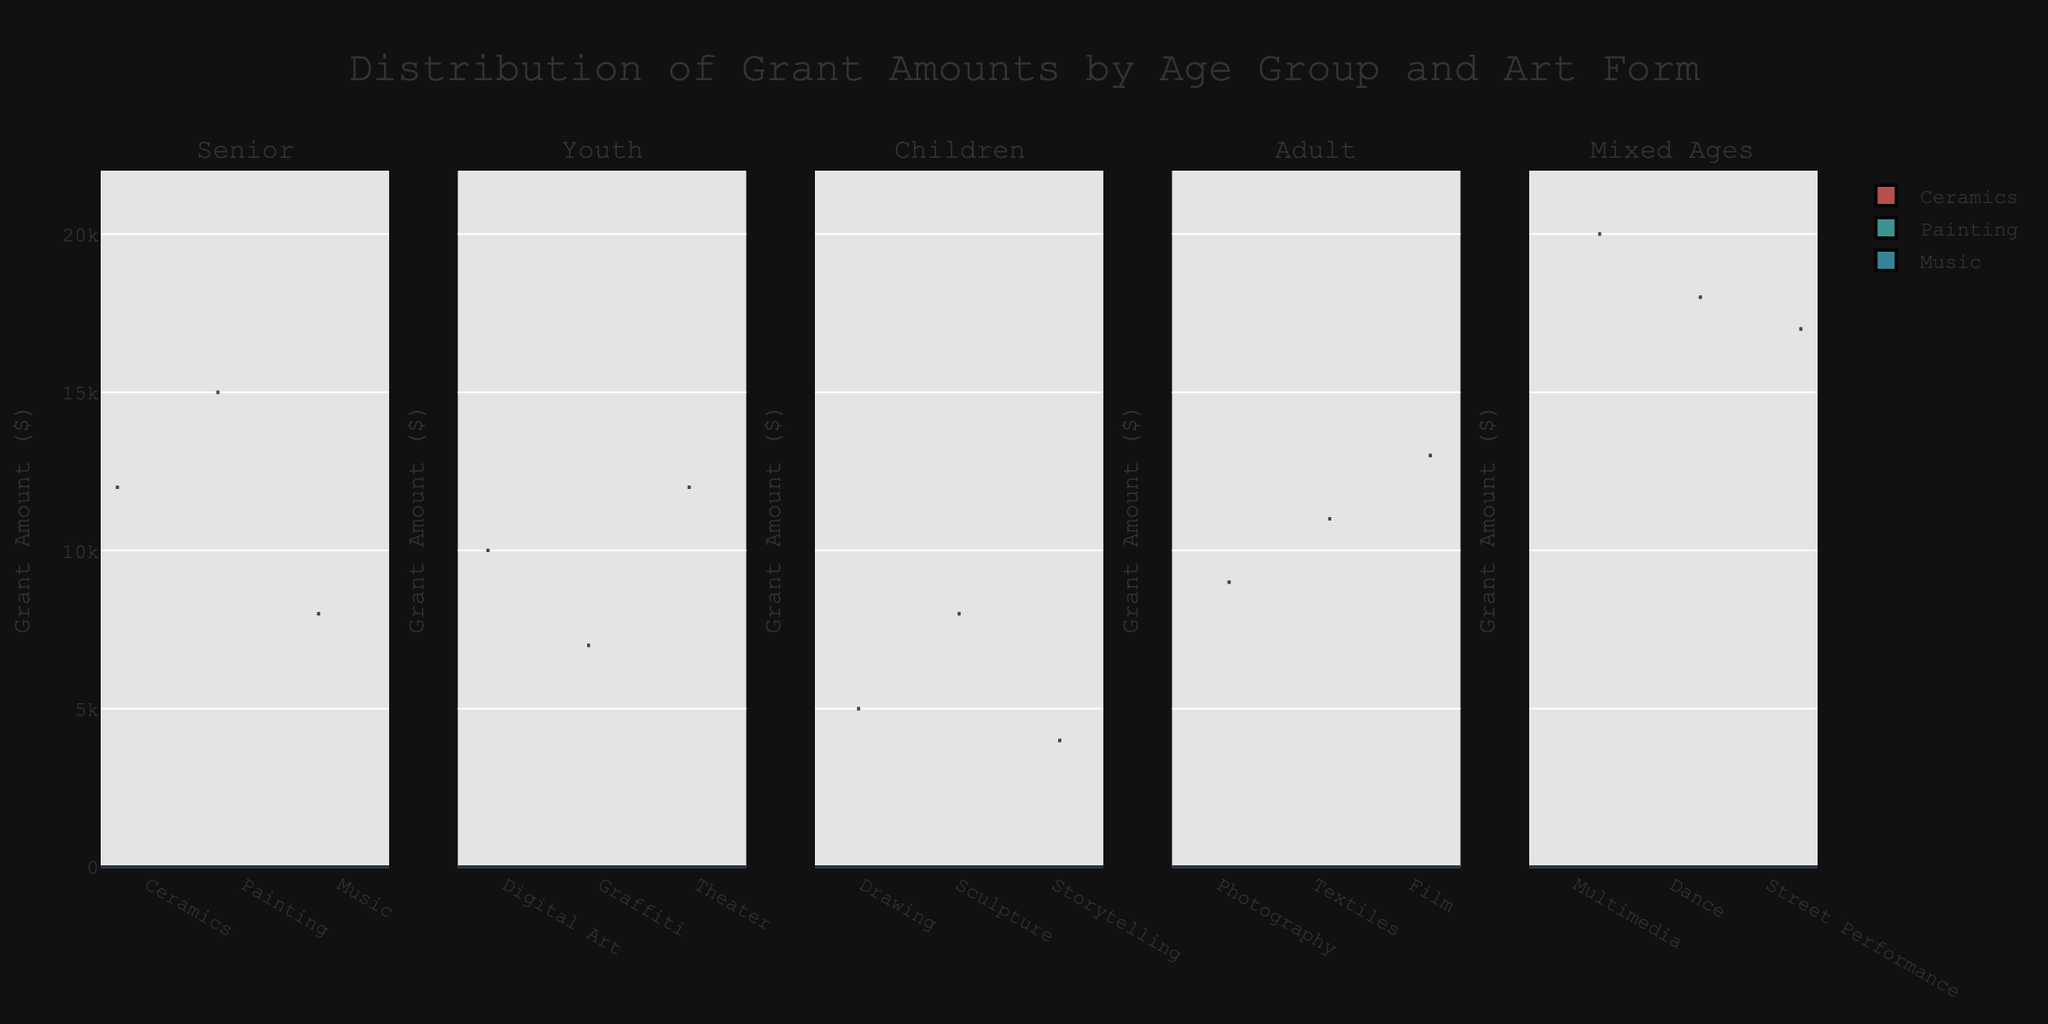What's the title of the figure? The title is usually located at the top of the figure. In this case, it reads "Distribution of Grant Amounts by Age Group and Art Form"
Answer: Distribution of Grant Amounts by Age Group and Art Form What does the y-axis represent? The y-axis shows the range of grant amounts in dollars given across different art forms and age groups
Answer: Grant Amount ($) Which age group has the highest median grant amount? By comparing the medians marked by the meanline in each subplot (vertical dash), the Mixed Ages group has the highest median around $18,000 to $20,000
Answer: Mixed Ages How many age groups are represented in the figure? The subplot titles indicate the age groups represented in the figure; they are Senior, Youth, Children, Adult, and Mixed Ages
Answer: Five In the Youth group, which art form received the highest grant amount? Within the Youth subplot, the highest grant amount can be seen in the theater violin plot
Answer: Theater Which art form has the widest distribution of grant amounts in Mixed Ages? In the Mixed Ages subplot, the Multimedia art form shows the widest distribution of values from around $15,000 to $20,000
Answer: Multimedia Compare the range of grant amounts between Theater for Youth and Film for Adults The range for Youth Theater is roughly $7,000 to $12,000 while for Adult Film it's from $9,000 to $13,000, so the Adult Film has a higher range
Answer: Adult Film has a higher range Are there any art forms that appear in all age groups? By inspecting each subplot, it's clear that no single art form appears across all age groups, as each group has unique art forms
Answer: No What's the color given to the Ceramics art form in the plot? The Ceramics art form is represented in the Senior group with a distinct color which, in this plot, appears as a shade of red
Answer: Red 